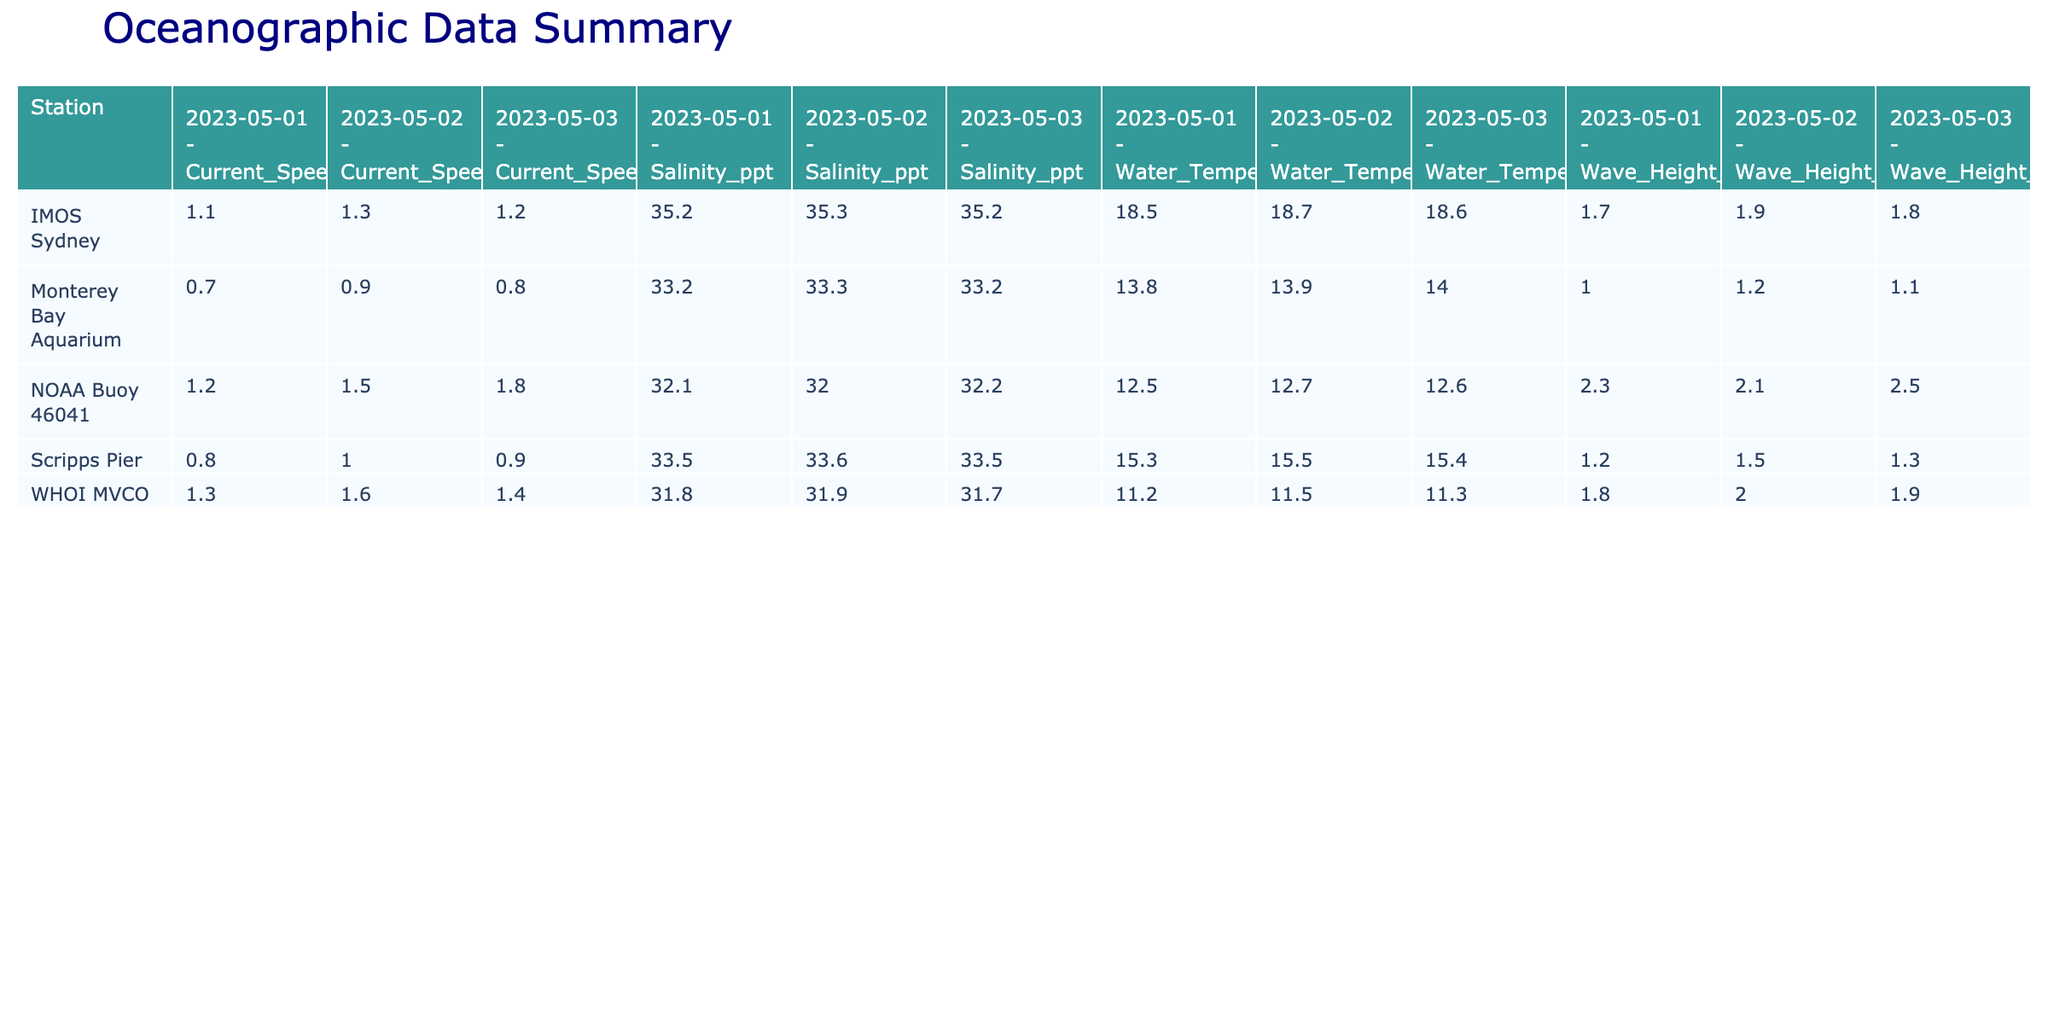What is the current speed recorded at NOAA Buoy 46041 on 2023-05-03? The table shows that the current speed at NOAA Buoy 46041 for the date 2023-05-03 is 1.8 knots, as indicated by the corresponding cell value.
Answer: 1.8 knots What is the highest wave height recorded at the Scripps Pier? By examining the Scripps Pier's entries in the table, the wave heights are 1.2, 1.5, and 1.3 meters. The maximum value is 1.5 meters, which is the highest recorded.
Answer: 1.5 meters Is the average water temperature higher at IMOS Sydney or at NOAA Buoy 46041? To find the average for IMOS Sydney, sum the water temperatures (18.5, 18.7, 18.6) and divide by 3, which equals 18.6°C. For NOAA Buoy 46041, sum (12.5, 12.7, 12.6) and divide by 3, which equals 12.6°C. Since 18.6°C > 12.6°C, IMOS Sydney has a higher average water temperature.
Answer: Yes What is the difference in average salinity between WHOI MVCO and Monterey Bay Aquarium? For WHOI MVCO, the salinity values are 31.8, 31.9, and 31.7, averaging to 31.8 ppt. For Monterey Bay Aquarium, the salinities are 33.2, 33.3, and 33.2, averaging to 33.3 ppt. The difference is 33.3 - 31.8 = 1.5 ppt.
Answer: 1.5 ppt What is the wave period with the lowest recorded value at NOAA Buoy 46041? The table shows that the wave periods at NOAA Buoy 46041 are 8, 7, and 9 seconds. The lowest value among these is 7 seconds.
Answer: 7 seconds What was the maximum current speed recorded among all stations on 2023-05-02? By checking all stations for 2023-05-02, the current speeds are 1.5 (NOAA Buoy 46041), 1.0 (Scripps Pier), 1.6 (WHOI MVCO), 0.9 (Monterey Bay Aquarium), and 1.3 (IMOS Sydney). The maximum value is 1.6 knots at WHOI MVCO.
Answer: 1.6 knots Were there any instances of wave heights exceeding 2 meters across all stations? By inspecting the wave height values for all stations, the maximum recorded wave height is 2.5 meters at NOAA Buoy 46041, which does exceed 2 meters. Therefore, there were instances of wave heights exceeding 2 meters.
Answer: Yes Which station had the highest recorded water temperature on 2023-05-03? The recorded water temperatures on 2023-05-03 are: NOAA Buoy 46041: 12.6°C, Scripps Pier: 15.4°C, WHOI MVCO: 11.3°C, Monterey Bay Aquarium: 14.0°C, and IMOS Sydney: 18.6°C. The highest value is 18.6°C at IMOS Sydney.
Answer: IMOS Sydney 